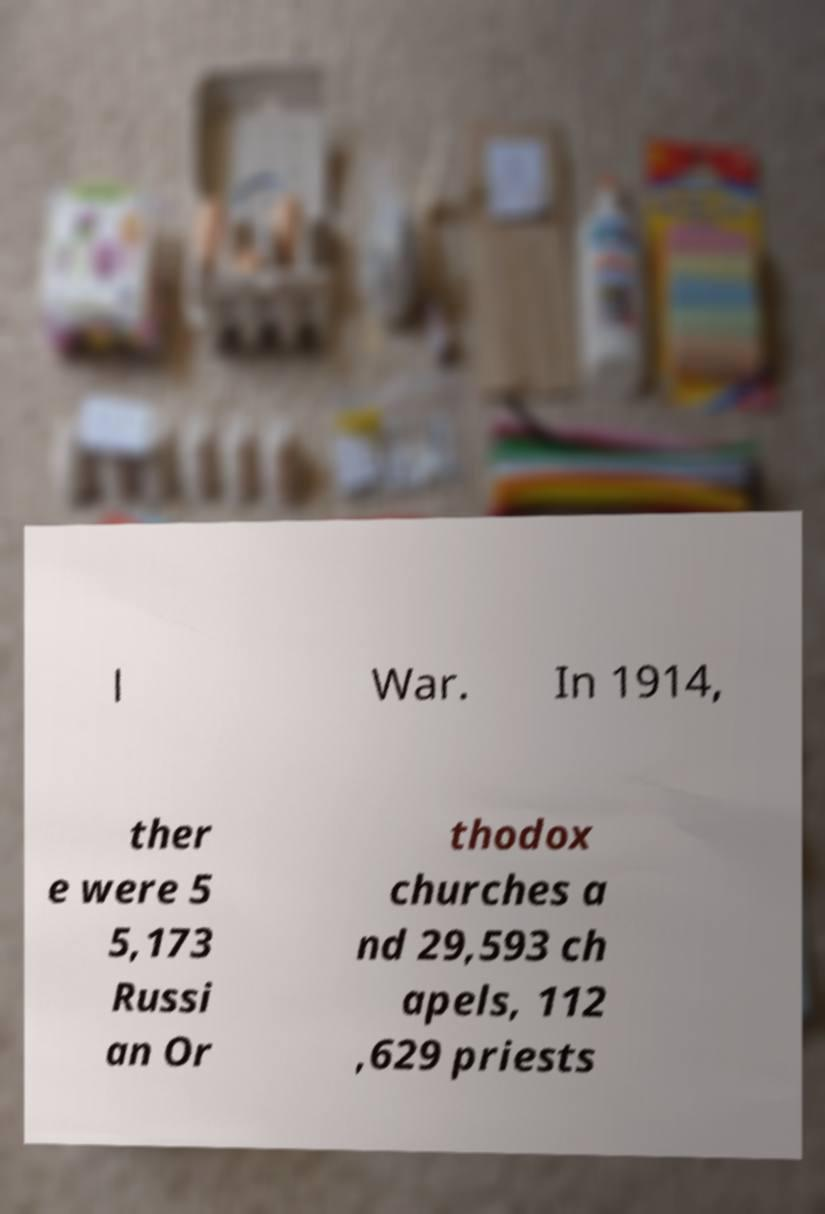Please read and relay the text visible in this image. What does it say? l War. In 1914, ther e were 5 5,173 Russi an Or thodox churches a nd 29,593 ch apels, 112 ,629 priests 